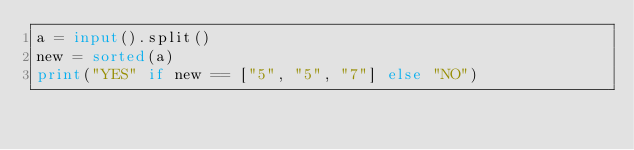<code> <loc_0><loc_0><loc_500><loc_500><_Python_>a = input().split()
new = sorted(a)
print("YES" if new == ["5", "5", "7"] else "NO")</code> 